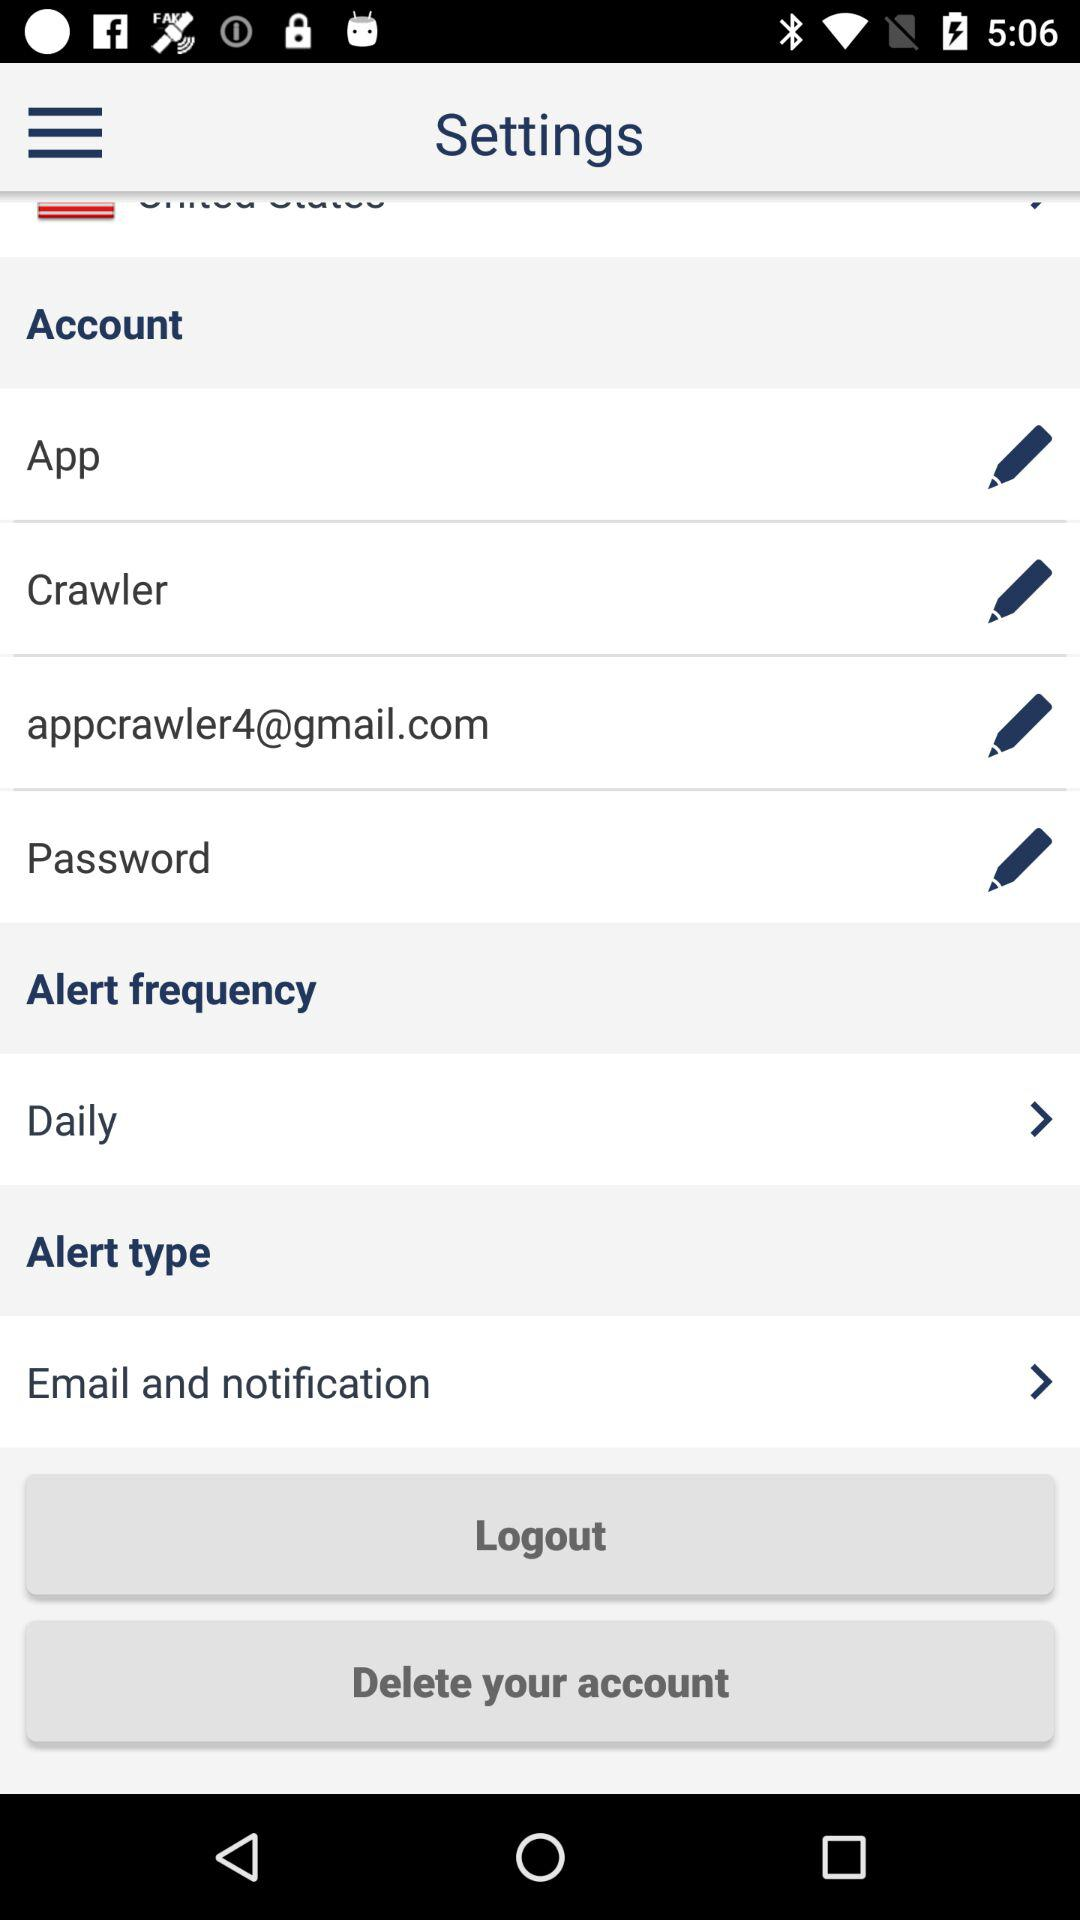What email address is used? The used email address is appcrawler4@gmail.com. 